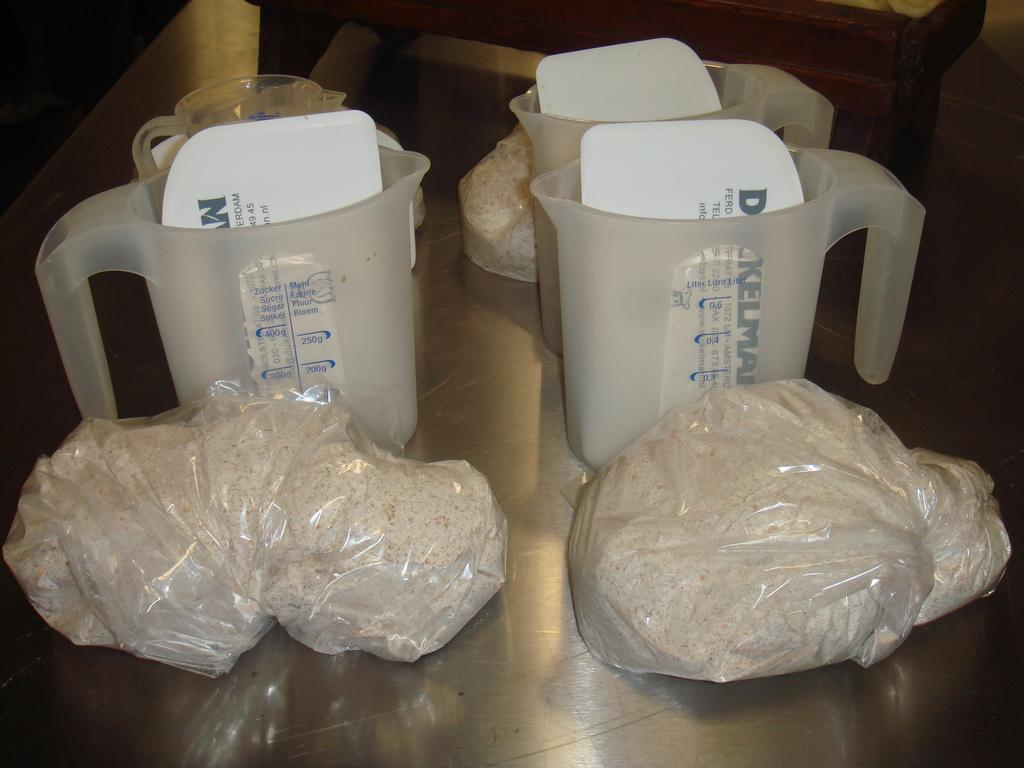What type of containers are visible in the image? There are plastic bags with objects and jars with papers inside in the image. Where are the jars located? The jars are on the floor. What can be seen in the background of the image? There is a table-like object in the background of the image. How many icicles are hanging from the table-like object in the image? There are no icicles present in the image. What part of the body can be seen in the image? There is no part of the body visible in the image. 